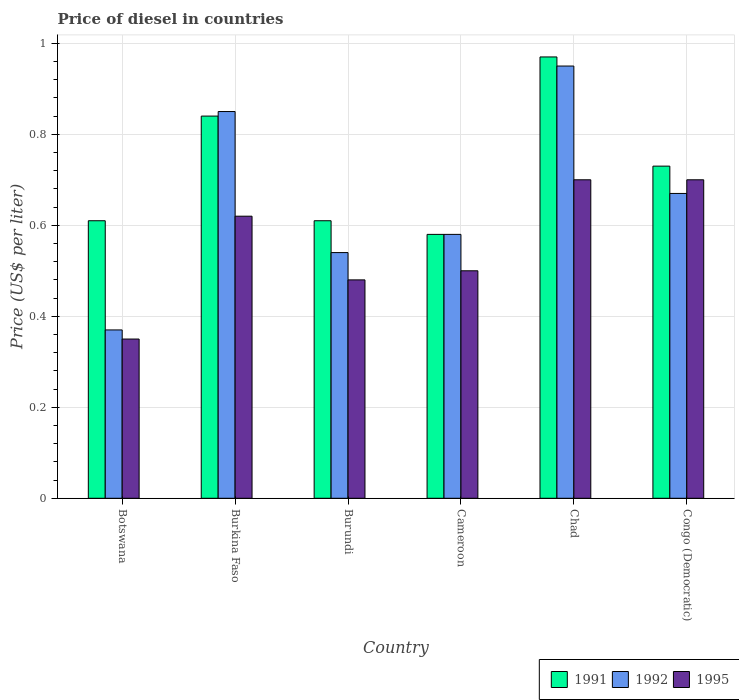How many different coloured bars are there?
Make the answer very short. 3. What is the label of the 2nd group of bars from the left?
Offer a terse response. Burkina Faso. What is the price of diesel in 1992 in Chad?
Your response must be concise. 0.95. Across all countries, what is the maximum price of diesel in 1995?
Provide a short and direct response. 0.7. Across all countries, what is the minimum price of diesel in 1991?
Make the answer very short. 0.58. In which country was the price of diesel in 1995 maximum?
Provide a succinct answer. Chad. In which country was the price of diesel in 1992 minimum?
Give a very brief answer. Botswana. What is the total price of diesel in 1995 in the graph?
Ensure brevity in your answer.  3.35. What is the difference between the price of diesel in 1992 in Cameroon and that in Chad?
Your response must be concise. -0.37. What is the difference between the price of diesel in 1992 in Chad and the price of diesel in 1995 in Burkina Faso?
Offer a terse response. 0.33. What is the average price of diesel in 1991 per country?
Offer a very short reply. 0.72. What is the difference between the price of diesel of/in 1995 and price of diesel of/in 1992 in Cameroon?
Provide a short and direct response. -0.08. In how many countries, is the price of diesel in 1991 greater than 0.68 US$?
Give a very brief answer. 3. What is the ratio of the price of diesel in 1992 in Burkina Faso to that in Congo (Democratic)?
Give a very brief answer. 1.27. What is the difference between the highest and the second highest price of diesel in 1992?
Ensure brevity in your answer.  0.1. What is the difference between the highest and the lowest price of diesel in 1995?
Ensure brevity in your answer.  0.35. What does the 1st bar from the right in Cameroon represents?
Provide a short and direct response. 1995. Is it the case that in every country, the sum of the price of diesel in 1992 and price of diesel in 1995 is greater than the price of diesel in 1991?
Provide a succinct answer. Yes. How many bars are there?
Offer a very short reply. 18. Are all the bars in the graph horizontal?
Make the answer very short. No. What is the difference between two consecutive major ticks on the Y-axis?
Offer a very short reply. 0.2. Does the graph contain grids?
Provide a succinct answer. Yes. Where does the legend appear in the graph?
Ensure brevity in your answer.  Bottom right. How many legend labels are there?
Provide a short and direct response. 3. How are the legend labels stacked?
Ensure brevity in your answer.  Horizontal. What is the title of the graph?
Offer a very short reply. Price of diesel in countries. Does "1964" appear as one of the legend labels in the graph?
Offer a terse response. No. What is the label or title of the Y-axis?
Provide a succinct answer. Price (US$ per liter). What is the Price (US$ per liter) in 1991 in Botswana?
Provide a short and direct response. 0.61. What is the Price (US$ per liter) of 1992 in Botswana?
Keep it short and to the point. 0.37. What is the Price (US$ per liter) in 1995 in Botswana?
Provide a succinct answer. 0.35. What is the Price (US$ per liter) in 1991 in Burkina Faso?
Provide a short and direct response. 0.84. What is the Price (US$ per liter) of 1992 in Burkina Faso?
Provide a succinct answer. 0.85. What is the Price (US$ per liter) of 1995 in Burkina Faso?
Provide a succinct answer. 0.62. What is the Price (US$ per liter) in 1991 in Burundi?
Ensure brevity in your answer.  0.61. What is the Price (US$ per liter) of 1992 in Burundi?
Provide a succinct answer. 0.54. What is the Price (US$ per liter) in 1995 in Burundi?
Your answer should be compact. 0.48. What is the Price (US$ per liter) of 1991 in Cameroon?
Ensure brevity in your answer.  0.58. What is the Price (US$ per liter) in 1992 in Cameroon?
Your answer should be very brief. 0.58. What is the Price (US$ per liter) of 1995 in Cameroon?
Your answer should be very brief. 0.5. What is the Price (US$ per liter) of 1995 in Chad?
Your answer should be very brief. 0.7. What is the Price (US$ per liter) in 1991 in Congo (Democratic)?
Offer a very short reply. 0.73. What is the Price (US$ per liter) of 1992 in Congo (Democratic)?
Keep it short and to the point. 0.67. What is the Price (US$ per liter) of 1995 in Congo (Democratic)?
Your answer should be compact. 0.7. Across all countries, what is the maximum Price (US$ per liter) in 1991?
Your response must be concise. 0.97. Across all countries, what is the minimum Price (US$ per liter) in 1991?
Make the answer very short. 0.58. Across all countries, what is the minimum Price (US$ per liter) in 1992?
Ensure brevity in your answer.  0.37. Across all countries, what is the minimum Price (US$ per liter) of 1995?
Offer a very short reply. 0.35. What is the total Price (US$ per liter) in 1991 in the graph?
Provide a succinct answer. 4.34. What is the total Price (US$ per liter) of 1992 in the graph?
Your answer should be very brief. 3.96. What is the total Price (US$ per liter) of 1995 in the graph?
Your answer should be very brief. 3.35. What is the difference between the Price (US$ per liter) of 1991 in Botswana and that in Burkina Faso?
Provide a short and direct response. -0.23. What is the difference between the Price (US$ per liter) of 1992 in Botswana and that in Burkina Faso?
Provide a succinct answer. -0.48. What is the difference between the Price (US$ per liter) of 1995 in Botswana and that in Burkina Faso?
Provide a short and direct response. -0.27. What is the difference between the Price (US$ per liter) of 1991 in Botswana and that in Burundi?
Offer a very short reply. 0. What is the difference between the Price (US$ per liter) of 1992 in Botswana and that in Burundi?
Make the answer very short. -0.17. What is the difference between the Price (US$ per liter) of 1995 in Botswana and that in Burundi?
Your response must be concise. -0.13. What is the difference between the Price (US$ per liter) of 1991 in Botswana and that in Cameroon?
Make the answer very short. 0.03. What is the difference between the Price (US$ per liter) of 1992 in Botswana and that in Cameroon?
Your response must be concise. -0.21. What is the difference between the Price (US$ per liter) of 1995 in Botswana and that in Cameroon?
Ensure brevity in your answer.  -0.15. What is the difference between the Price (US$ per liter) in 1991 in Botswana and that in Chad?
Keep it short and to the point. -0.36. What is the difference between the Price (US$ per liter) of 1992 in Botswana and that in Chad?
Provide a short and direct response. -0.58. What is the difference between the Price (US$ per liter) in 1995 in Botswana and that in Chad?
Offer a terse response. -0.35. What is the difference between the Price (US$ per liter) in 1991 in Botswana and that in Congo (Democratic)?
Offer a very short reply. -0.12. What is the difference between the Price (US$ per liter) in 1992 in Botswana and that in Congo (Democratic)?
Provide a succinct answer. -0.3. What is the difference between the Price (US$ per liter) of 1995 in Botswana and that in Congo (Democratic)?
Ensure brevity in your answer.  -0.35. What is the difference between the Price (US$ per liter) in 1991 in Burkina Faso and that in Burundi?
Offer a terse response. 0.23. What is the difference between the Price (US$ per liter) in 1992 in Burkina Faso and that in Burundi?
Offer a very short reply. 0.31. What is the difference between the Price (US$ per liter) of 1995 in Burkina Faso and that in Burundi?
Your answer should be very brief. 0.14. What is the difference between the Price (US$ per liter) of 1991 in Burkina Faso and that in Cameroon?
Your answer should be very brief. 0.26. What is the difference between the Price (US$ per liter) in 1992 in Burkina Faso and that in Cameroon?
Provide a succinct answer. 0.27. What is the difference between the Price (US$ per liter) of 1995 in Burkina Faso and that in Cameroon?
Provide a short and direct response. 0.12. What is the difference between the Price (US$ per liter) of 1991 in Burkina Faso and that in Chad?
Make the answer very short. -0.13. What is the difference between the Price (US$ per liter) in 1992 in Burkina Faso and that in Chad?
Provide a succinct answer. -0.1. What is the difference between the Price (US$ per liter) in 1995 in Burkina Faso and that in Chad?
Your answer should be compact. -0.08. What is the difference between the Price (US$ per liter) in 1991 in Burkina Faso and that in Congo (Democratic)?
Your answer should be very brief. 0.11. What is the difference between the Price (US$ per liter) in 1992 in Burkina Faso and that in Congo (Democratic)?
Make the answer very short. 0.18. What is the difference between the Price (US$ per liter) of 1995 in Burkina Faso and that in Congo (Democratic)?
Your answer should be very brief. -0.08. What is the difference between the Price (US$ per liter) in 1991 in Burundi and that in Cameroon?
Your answer should be very brief. 0.03. What is the difference between the Price (US$ per liter) in 1992 in Burundi and that in Cameroon?
Offer a very short reply. -0.04. What is the difference between the Price (US$ per liter) in 1995 in Burundi and that in Cameroon?
Give a very brief answer. -0.02. What is the difference between the Price (US$ per liter) of 1991 in Burundi and that in Chad?
Provide a succinct answer. -0.36. What is the difference between the Price (US$ per liter) in 1992 in Burundi and that in Chad?
Ensure brevity in your answer.  -0.41. What is the difference between the Price (US$ per liter) of 1995 in Burundi and that in Chad?
Make the answer very short. -0.22. What is the difference between the Price (US$ per liter) in 1991 in Burundi and that in Congo (Democratic)?
Provide a short and direct response. -0.12. What is the difference between the Price (US$ per liter) of 1992 in Burundi and that in Congo (Democratic)?
Ensure brevity in your answer.  -0.13. What is the difference between the Price (US$ per liter) in 1995 in Burundi and that in Congo (Democratic)?
Your answer should be compact. -0.22. What is the difference between the Price (US$ per liter) in 1991 in Cameroon and that in Chad?
Your response must be concise. -0.39. What is the difference between the Price (US$ per liter) in 1992 in Cameroon and that in Chad?
Your response must be concise. -0.37. What is the difference between the Price (US$ per liter) of 1991 in Cameroon and that in Congo (Democratic)?
Give a very brief answer. -0.15. What is the difference between the Price (US$ per liter) of 1992 in Cameroon and that in Congo (Democratic)?
Your answer should be compact. -0.09. What is the difference between the Price (US$ per liter) in 1991 in Chad and that in Congo (Democratic)?
Provide a succinct answer. 0.24. What is the difference between the Price (US$ per liter) of 1992 in Chad and that in Congo (Democratic)?
Offer a very short reply. 0.28. What is the difference between the Price (US$ per liter) of 1995 in Chad and that in Congo (Democratic)?
Ensure brevity in your answer.  0. What is the difference between the Price (US$ per liter) of 1991 in Botswana and the Price (US$ per liter) of 1992 in Burkina Faso?
Ensure brevity in your answer.  -0.24. What is the difference between the Price (US$ per liter) of 1991 in Botswana and the Price (US$ per liter) of 1995 in Burkina Faso?
Offer a terse response. -0.01. What is the difference between the Price (US$ per liter) in 1992 in Botswana and the Price (US$ per liter) in 1995 in Burkina Faso?
Keep it short and to the point. -0.25. What is the difference between the Price (US$ per liter) of 1991 in Botswana and the Price (US$ per liter) of 1992 in Burundi?
Provide a short and direct response. 0.07. What is the difference between the Price (US$ per liter) in 1991 in Botswana and the Price (US$ per liter) in 1995 in Burundi?
Give a very brief answer. 0.13. What is the difference between the Price (US$ per liter) in 1992 in Botswana and the Price (US$ per liter) in 1995 in Burundi?
Make the answer very short. -0.11. What is the difference between the Price (US$ per liter) in 1991 in Botswana and the Price (US$ per liter) in 1995 in Cameroon?
Your answer should be very brief. 0.11. What is the difference between the Price (US$ per liter) in 1992 in Botswana and the Price (US$ per liter) in 1995 in Cameroon?
Give a very brief answer. -0.13. What is the difference between the Price (US$ per liter) in 1991 in Botswana and the Price (US$ per liter) in 1992 in Chad?
Offer a terse response. -0.34. What is the difference between the Price (US$ per liter) of 1991 in Botswana and the Price (US$ per liter) of 1995 in Chad?
Provide a succinct answer. -0.09. What is the difference between the Price (US$ per liter) of 1992 in Botswana and the Price (US$ per liter) of 1995 in Chad?
Ensure brevity in your answer.  -0.33. What is the difference between the Price (US$ per liter) in 1991 in Botswana and the Price (US$ per liter) in 1992 in Congo (Democratic)?
Provide a short and direct response. -0.06. What is the difference between the Price (US$ per liter) of 1991 in Botswana and the Price (US$ per liter) of 1995 in Congo (Democratic)?
Keep it short and to the point. -0.09. What is the difference between the Price (US$ per liter) of 1992 in Botswana and the Price (US$ per liter) of 1995 in Congo (Democratic)?
Offer a very short reply. -0.33. What is the difference between the Price (US$ per liter) of 1991 in Burkina Faso and the Price (US$ per liter) of 1995 in Burundi?
Keep it short and to the point. 0.36. What is the difference between the Price (US$ per liter) of 1992 in Burkina Faso and the Price (US$ per liter) of 1995 in Burundi?
Provide a succinct answer. 0.37. What is the difference between the Price (US$ per liter) in 1991 in Burkina Faso and the Price (US$ per liter) in 1992 in Cameroon?
Give a very brief answer. 0.26. What is the difference between the Price (US$ per liter) in 1991 in Burkina Faso and the Price (US$ per liter) in 1995 in Cameroon?
Your response must be concise. 0.34. What is the difference between the Price (US$ per liter) in 1991 in Burkina Faso and the Price (US$ per liter) in 1992 in Chad?
Provide a succinct answer. -0.11. What is the difference between the Price (US$ per liter) in 1991 in Burkina Faso and the Price (US$ per liter) in 1995 in Chad?
Provide a short and direct response. 0.14. What is the difference between the Price (US$ per liter) of 1991 in Burkina Faso and the Price (US$ per liter) of 1992 in Congo (Democratic)?
Your answer should be very brief. 0.17. What is the difference between the Price (US$ per liter) of 1991 in Burkina Faso and the Price (US$ per liter) of 1995 in Congo (Democratic)?
Make the answer very short. 0.14. What is the difference between the Price (US$ per liter) of 1992 in Burkina Faso and the Price (US$ per liter) of 1995 in Congo (Democratic)?
Your response must be concise. 0.15. What is the difference between the Price (US$ per liter) of 1991 in Burundi and the Price (US$ per liter) of 1995 in Cameroon?
Give a very brief answer. 0.11. What is the difference between the Price (US$ per liter) in 1991 in Burundi and the Price (US$ per liter) in 1992 in Chad?
Make the answer very short. -0.34. What is the difference between the Price (US$ per liter) in 1991 in Burundi and the Price (US$ per liter) in 1995 in Chad?
Make the answer very short. -0.09. What is the difference between the Price (US$ per liter) in 1992 in Burundi and the Price (US$ per liter) in 1995 in Chad?
Provide a succinct answer. -0.16. What is the difference between the Price (US$ per liter) in 1991 in Burundi and the Price (US$ per liter) in 1992 in Congo (Democratic)?
Offer a very short reply. -0.06. What is the difference between the Price (US$ per liter) in 1991 in Burundi and the Price (US$ per liter) in 1995 in Congo (Democratic)?
Ensure brevity in your answer.  -0.09. What is the difference between the Price (US$ per liter) of 1992 in Burundi and the Price (US$ per liter) of 1995 in Congo (Democratic)?
Your answer should be compact. -0.16. What is the difference between the Price (US$ per liter) of 1991 in Cameroon and the Price (US$ per liter) of 1992 in Chad?
Ensure brevity in your answer.  -0.37. What is the difference between the Price (US$ per liter) of 1991 in Cameroon and the Price (US$ per liter) of 1995 in Chad?
Offer a very short reply. -0.12. What is the difference between the Price (US$ per liter) in 1992 in Cameroon and the Price (US$ per liter) in 1995 in Chad?
Your response must be concise. -0.12. What is the difference between the Price (US$ per liter) in 1991 in Cameroon and the Price (US$ per liter) in 1992 in Congo (Democratic)?
Offer a very short reply. -0.09. What is the difference between the Price (US$ per liter) in 1991 in Cameroon and the Price (US$ per liter) in 1995 in Congo (Democratic)?
Ensure brevity in your answer.  -0.12. What is the difference between the Price (US$ per liter) in 1992 in Cameroon and the Price (US$ per liter) in 1995 in Congo (Democratic)?
Ensure brevity in your answer.  -0.12. What is the difference between the Price (US$ per liter) of 1991 in Chad and the Price (US$ per liter) of 1995 in Congo (Democratic)?
Keep it short and to the point. 0.27. What is the difference between the Price (US$ per liter) of 1992 in Chad and the Price (US$ per liter) of 1995 in Congo (Democratic)?
Your answer should be very brief. 0.25. What is the average Price (US$ per liter) of 1991 per country?
Provide a short and direct response. 0.72. What is the average Price (US$ per liter) of 1992 per country?
Offer a terse response. 0.66. What is the average Price (US$ per liter) of 1995 per country?
Offer a terse response. 0.56. What is the difference between the Price (US$ per liter) of 1991 and Price (US$ per liter) of 1992 in Botswana?
Offer a terse response. 0.24. What is the difference between the Price (US$ per liter) in 1991 and Price (US$ per liter) in 1995 in Botswana?
Offer a very short reply. 0.26. What is the difference between the Price (US$ per liter) in 1992 and Price (US$ per liter) in 1995 in Botswana?
Your answer should be compact. 0.02. What is the difference between the Price (US$ per liter) in 1991 and Price (US$ per liter) in 1992 in Burkina Faso?
Give a very brief answer. -0.01. What is the difference between the Price (US$ per liter) in 1991 and Price (US$ per liter) in 1995 in Burkina Faso?
Keep it short and to the point. 0.22. What is the difference between the Price (US$ per liter) in 1992 and Price (US$ per liter) in 1995 in Burkina Faso?
Give a very brief answer. 0.23. What is the difference between the Price (US$ per liter) in 1991 and Price (US$ per liter) in 1992 in Burundi?
Keep it short and to the point. 0.07. What is the difference between the Price (US$ per liter) of 1991 and Price (US$ per liter) of 1995 in Burundi?
Your answer should be very brief. 0.13. What is the difference between the Price (US$ per liter) in 1992 and Price (US$ per liter) in 1995 in Burundi?
Offer a very short reply. 0.06. What is the difference between the Price (US$ per liter) in 1991 and Price (US$ per liter) in 1995 in Cameroon?
Give a very brief answer. 0.08. What is the difference between the Price (US$ per liter) in 1992 and Price (US$ per liter) in 1995 in Cameroon?
Offer a very short reply. 0.08. What is the difference between the Price (US$ per liter) in 1991 and Price (US$ per liter) in 1992 in Chad?
Offer a terse response. 0.02. What is the difference between the Price (US$ per liter) of 1991 and Price (US$ per liter) of 1995 in Chad?
Provide a succinct answer. 0.27. What is the difference between the Price (US$ per liter) of 1991 and Price (US$ per liter) of 1992 in Congo (Democratic)?
Offer a very short reply. 0.06. What is the difference between the Price (US$ per liter) in 1991 and Price (US$ per liter) in 1995 in Congo (Democratic)?
Offer a terse response. 0.03. What is the difference between the Price (US$ per liter) in 1992 and Price (US$ per liter) in 1995 in Congo (Democratic)?
Make the answer very short. -0.03. What is the ratio of the Price (US$ per liter) of 1991 in Botswana to that in Burkina Faso?
Offer a terse response. 0.73. What is the ratio of the Price (US$ per liter) in 1992 in Botswana to that in Burkina Faso?
Make the answer very short. 0.44. What is the ratio of the Price (US$ per liter) in 1995 in Botswana to that in Burkina Faso?
Your answer should be compact. 0.56. What is the ratio of the Price (US$ per liter) in 1991 in Botswana to that in Burundi?
Make the answer very short. 1. What is the ratio of the Price (US$ per liter) in 1992 in Botswana to that in Burundi?
Provide a succinct answer. 0.69. What is the ratio of the Price (US$ per liter) in 1995 in Botswana to that in Burundi?
Your answer should be very brief. 0.73. What is the ratio of the Price (US$ per liter) in 1991 in Botswana to that in Cameroon?
Provide a succinct answer. 1.05. What is the ratio of the Price (US$ per liter) in 1992 in Botswana to that in Cameroon?
Provide a succinct answer. 0.64. What is the ratio of the Price (US$ per liter) of 1991 in Botswana to that in Chad?
Keep it short and to the point. 0.63. What is the ratio of the Price (US$ per liter) of 1992 in Botswana to that in Chad?
Keep it short and to the point. 0.39. What is the ratio of the Price (US$ per liter) of 1991 in Botswana to that in Congo (Democratic)?
Keep it short and to the point. 0.84. What is the ratio of the Price (US$ per liter) in 1992 in Botswana to that in Congo (Democratic)?
Provide a succinct answer. 0.55. What is the ratio of the Price (US$ per liter) of 1995 in Botswana to that in Congo (Democratic)?
Keep it short and to the point. 0.5. What is the ratio of the Price (US$ per liter) in 1991 in Burkina Faso to that in Burundi?
Give a very brief answer. 1.38. What is the ratio of the Price (US$ per liter) of 1992 in Burkina Faso to that in Burundi?
Ensure brevity in your answer.  1.57. What is the ratio of the Price (US$ per liter) in 1995 in Burkina Faso to that in Burundi?
Your answer should be very brief. 1.29. What is the ratio of the Price (US$ per liter) of 1991 in Burkina Faso to that in Cameroon?
Ensure brevity in your answer.  1.45. What is the ratio of the Price (US$ per liter) of 1992 in Burkina Faso to that in Cameroon?
Offer a terse response. 1.47. What is the ratio of the Price (US$ per liter) of 1995 in Burkina Faso to that in Cameroon?
Offer a terse response. 1.24. What is the ratio of the Price (US$ per liter) in 1991 in Burkina Faso to that in Chad?
Your answer should be compact. 0.87. What is the ratio of the Price (US$ per liter) in 1992 in Burkina Faso to that in Chad?
Ensure brevity in your answer.  0.89. What is the ratio of the Price (US$ per liter) in 1995 in Burkina Faso to that in Chad?
Keep it short and to the point. 0.89. What is the ratio of the Price (US$ per liter) of 1991 in Burkina Faso to that in Congo (Democratic)?
Your response must be concise. 1.15. What is the ratio of the Price (US$ per liter) in 1992 in Burkina Faso to that in Congo (Democratic)?
Your answer should be very brief. 1.27. What is the ratio of the Price (US$ per liter) of 1995 in Burkina Faso to that in Congo (Democratic)?
Offer a terse response. 0.89. What is the ratio of the Price (US$ per liter) in 1991 in Burundi to that in Cameroon?
Your response must be concise. 1.05. What is the ratio of the Price (US$ per liter) in 1992 in Burundi to that in Cameroon?
Ensure brevity in your answer.  0.93. What is the ratio of the Price (US$ per liter) of 1995 in Burundi to that in Cameroon?
Keep it short and to the point. 0.96. What is the ratio of the Price (US$ per liter) in 1991 in Burundi to that in Chad?
Your response must be concise. 0.63. What is the ratio of the Price (US$ per liter) of 1992 in Burundi to that in Chad?
Give a very brief answer. 0.57. What is the ratio of the Price (US$ per liter) in 1995 in Burundi to that in Chad?
Provide a succinct answer. 0.69. What is the ratio of the Price (US$ per liter) in 1991 in Burundi to that in Congo (Democratic)?
Give a very brief answer. 0.84. What is the ratio of the Price (US$ per liter) of 1992 in Burundi to that in Congo (Democratic)?
Provide a short and direct response. 0.81. What is the ratio of the Price (US$ per liter) of 1995 in Burundi to that in Congo (Democratic)?
Provide a succinct answer. 0.69. What is the ratio of the Price (US$ per liter) of 1991 in Cameroon to that in Chad?
Give a very brief answer. 0.6. What is the ratio of the Price (US$ per liter) in 1992 in Cameroon to that in Chad?
Your answer should be compact. 0.61. What is the ratio of the Price (US$ per liter) of 1991 in Cameroon to that in Congo (Democratic)?
Your answer should be very brief. 0.79. What is the ratio of the Price (US$ per liter) in 1992 in Cameroon to that in Congo (Democratic)?
Offer a very short reply. 0.87. What is the ratio of the Price (US$ per liter) in 1991 in Chad to that in Congo (Democratic)?
Provide a succinct answer. 1.33. What is the ratio of the Price (US$ per liter) in 1992 in Chad to that in Congo (Democratic)?
Your answer should be compact. 1.42. What is the difference between the highest and the second highest Price (US$ per liter) in 1991?
Provide a short and direct response. 0.13. What is the difference between the highest and the lowest Price (US$ per liter) of 1991?
Make the answer very short. 0.39. What is the difference between the highest and the lowest Price (US$ per liter) in 1992?
Make the answer very short. 0.58. What is the difference between the highest and the lowest Price (US$ per liter) of 1995?
Offer a very short reply. 0.35. 